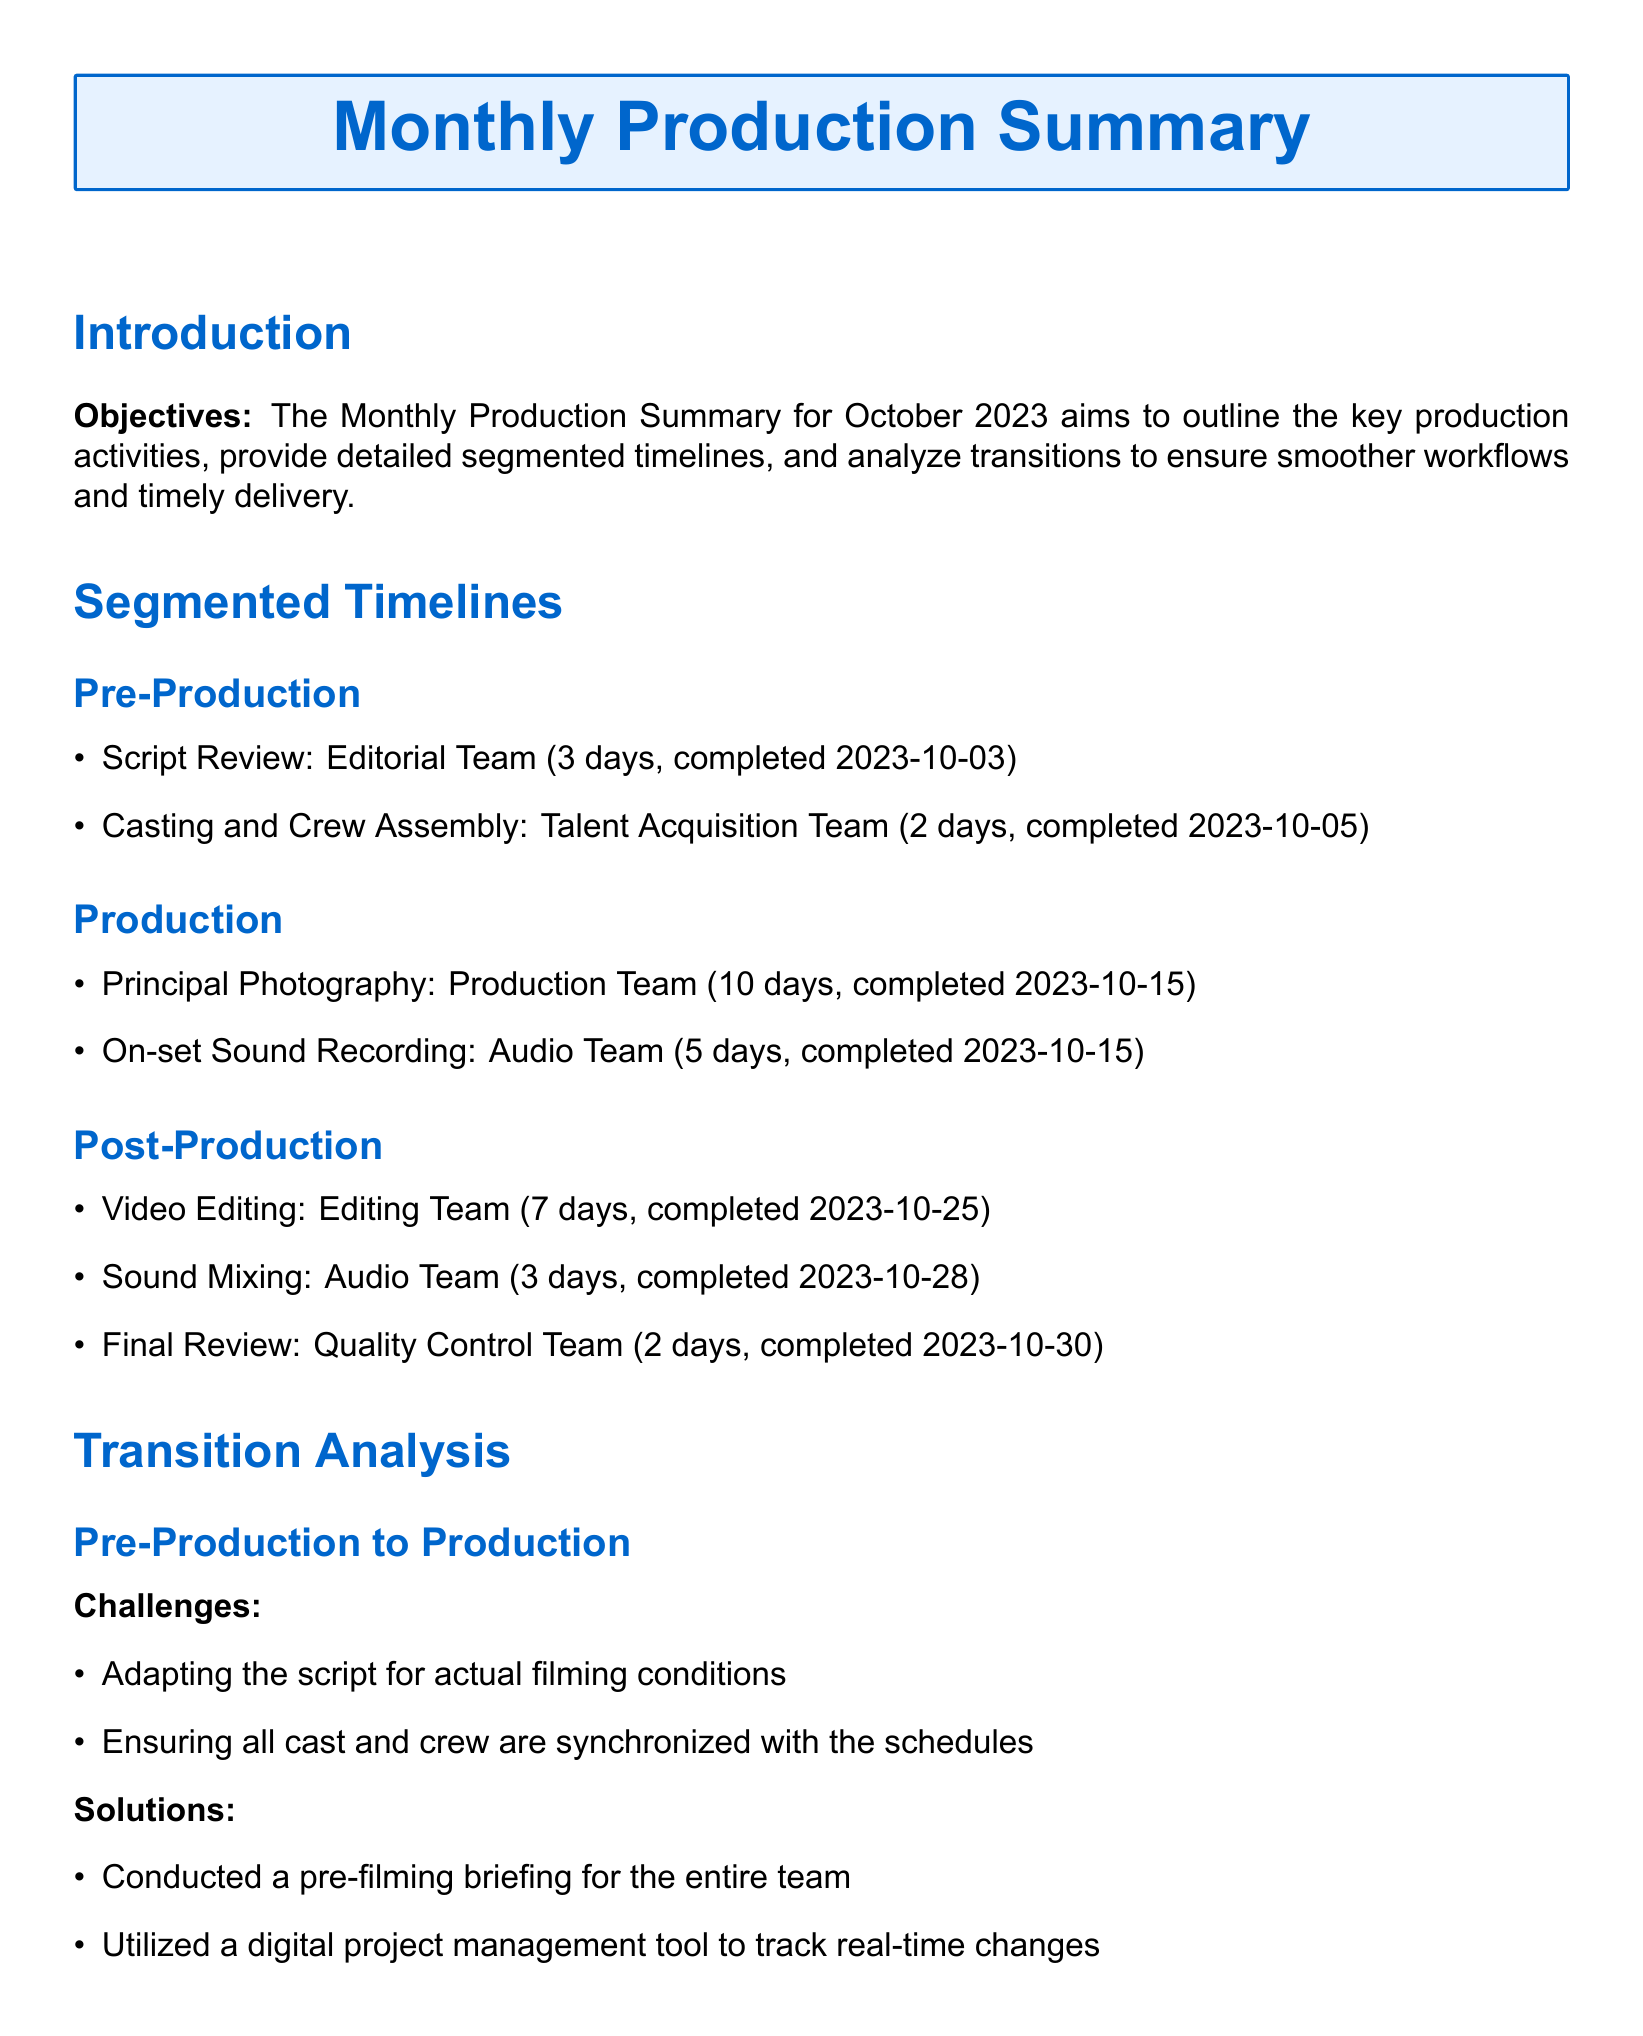What is the primary color used in the document? The primary color is specified within the document as RGB (0, 102, 204).
Answer: RGB (0, 102, 204) How many days did the script review take? The script review duration is explicitly stated in the document as 3 days.
Answer: 3 days When was the principal photography completed? The completion date for the principal photography is mentioned as 2023-10-15.
Answer: 2023-10-15 What team conducted the video editing? The team responsible for video editing is listed as the Editing Team.
Answer: Editing Team What was one of the challenges during the transition from Pre-Production to Production? The document lists adapting the script for actual filming conditions as a challenge.
Answer: Adapting the script for actual filming conditions What solution was implemented for timely transfers of raw footage? The document states the setup of an integrated file-sharing system as a solution.
Answer: Integrated file-sharing system How long did the final review take? The duration of the final review is recorded in the document as 2 days.
Answer: 2 days Which team is responsible for sound mixing? The sound mixing responsibility is assigned to the Audio Team in the document.
Answer: Audio Team What was the total duration of the production phase? The durations mentioned for production activities sum up to 15 days (10 + 5).
Answer: 15 days 